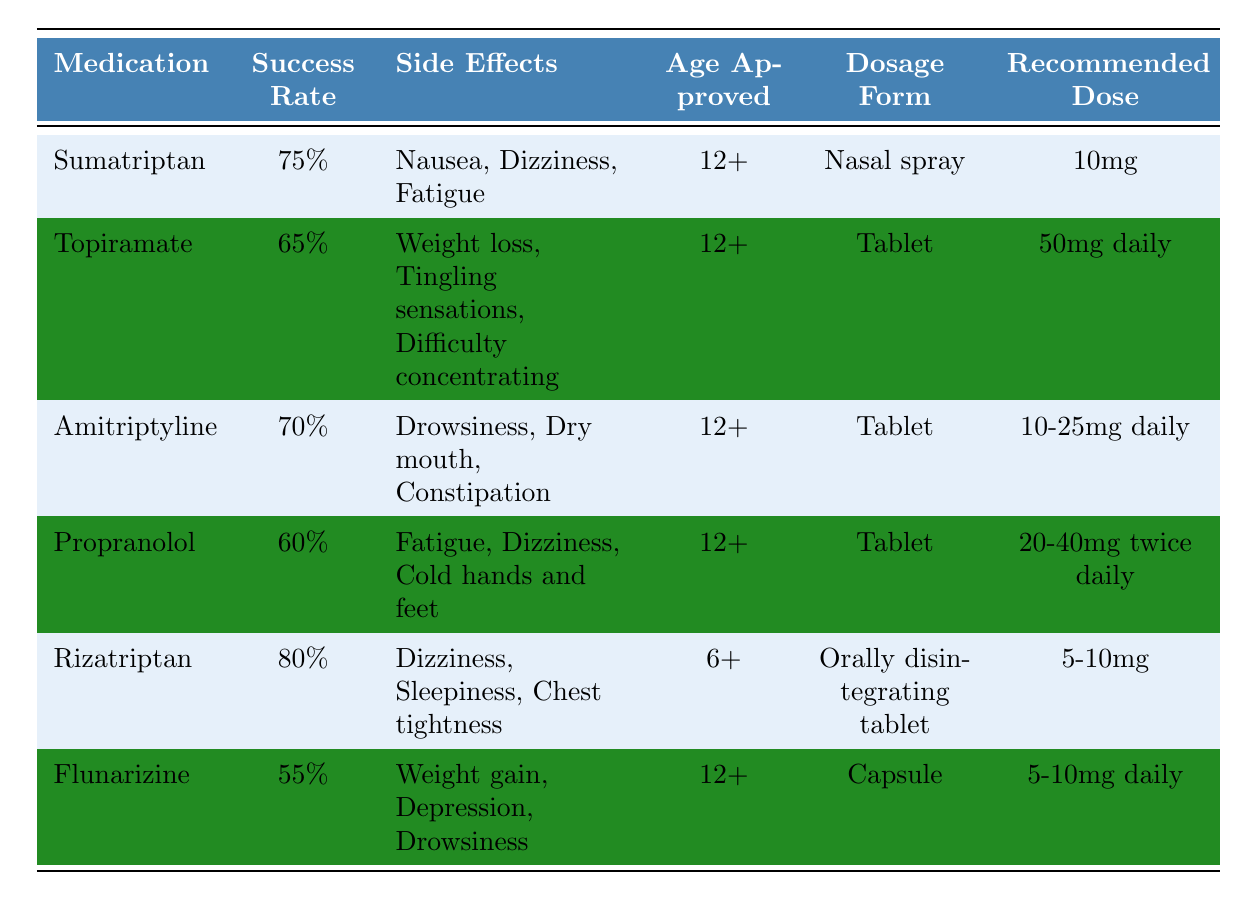What is the success rate of Sumatriptan? The table indicates that the success rate for Sumatriptan is listed directly alongside its name. It shows a success rate of 75%.
Answer: 75% Which medication has the lowest success rate? By reviewing the success rates of all the medications, Flunarizine has the lowest success rate at 55%.
Answer: Flunarizine How many medications are approved for use in adolescents aged 12 and older? The table shows five medications that have an age approval of 12 or older: Sumatriptan, Topiramate, Amitriptyline, Propranolol, and Flunarizine. This totals to five medications.
Answer: 5 What are the side effects of Rizatriptan? The side effects of Rizatriptan are listed directly in the table as Dizziness, Sleepiness, and Chest tightness.
Answer: Dizziness, Sleepiness, Chest tightness Is Amitriptyline more effective than Propranolol? Amitriptyline has a success rate of 70%, while Propranolol has a success rate of 60%. Since 70% is greater than 60%, Amitriptyline is indeed more effective.
Answer: Yes What is the average success rate of the medications listed in the table? To find the average, we add the success rates: 75 + 65 + 70 + 60 + 80 + 55 = 405. There are 6 medications, so we divide 405 by 6, which gives us 67.5.
Answer: 67.5% Which medication has more side effects, Amitriptyline or Topiramate? Amitriptyline has three side effects (Drowsiness, Dry mouth, Constipation), while Topiramate also has three side effects (Weight loss, Tingling sensations, Difficulty concentrating). Both have the same number of side effects.
Answer: Same (3 each) What is the recommended dose for Propranolol? The recommended dose for Propranolol is clearly mentioned in the table as 20-40mg twice daily.
Answer: 20-40mg twice daily Do all medications approved for adolescents aged 12 or older have side effects listed in the table? Yes, the table shows that all medications listed (Sumatriptan, Topiramate, Amitriptyline, Propranolol, Flunarizine) have corresponding side effects noted.
Answer: Yes Which medication is recommended for younger adolescents aged 6 and older? The table shows that Rizatriptan is approved for use in adolescents as young as 6 years old.
Answer: Rizatriptan If a parent is considering medication for their 12-year-old daughter, what would be the best option based on success rate? The medication with the highest success rate is Rizatriptan at 80%. Therefore, it would be the best option based on effectiveness.
Answer: Rizatriptan 